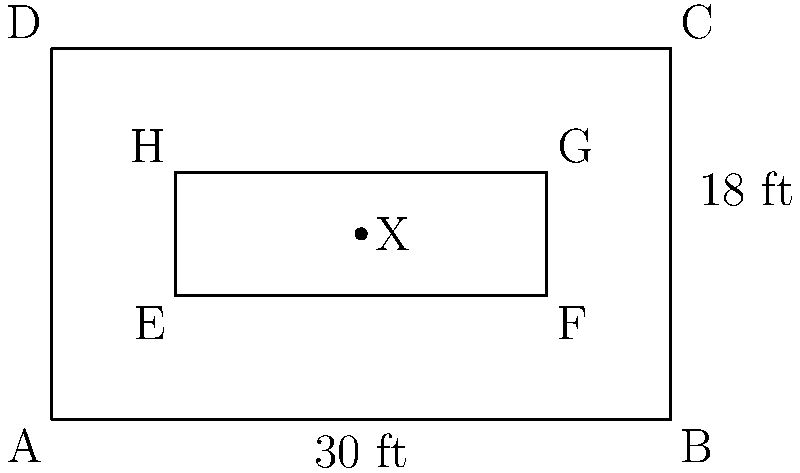In the floor plan for a new counseling facility, the outer rectangle ABCD represents the entire building, while the inner rectangle EFGH represents a group therapy room. If the actual width of the building is 30 feet and its length is 18 feet, what is the actual area of the group therapy room in square feet? Assume the scale is consistent throughout the plan. To solve this problem, we need to follow these steps:

1. Determine the scale of the drawing:
   - The width of the building (AB) is 10 units in the drawing and 30 feet in reality.
   - Scale: 1 unit = 3 feet (30 feet ÷ 10 units)

2. Calculate the dimensions of the group therapy room in the drawing:
   - Width (EF) = 6 units
   - Length (EH) = 2 units

3. Convert the drawing dimensions to actual dimensions:
   - Actual width = 6 units × 3 feet/unit = 18 feet
   - Actual length = 2 units × 3 feet/unit = 6 feet

4. Calculate the area of the group therapy room:
   $$ \text{Area} = \text{width} \times \text{length} $$
   $$ \text{Area} = 18 \text{ feet} \times 6 \text{ feet} = 108 \text{ square feet} $$

Therefore, the actual area of the group therapy room is 108 square feet.
Answer: 108 square feet 